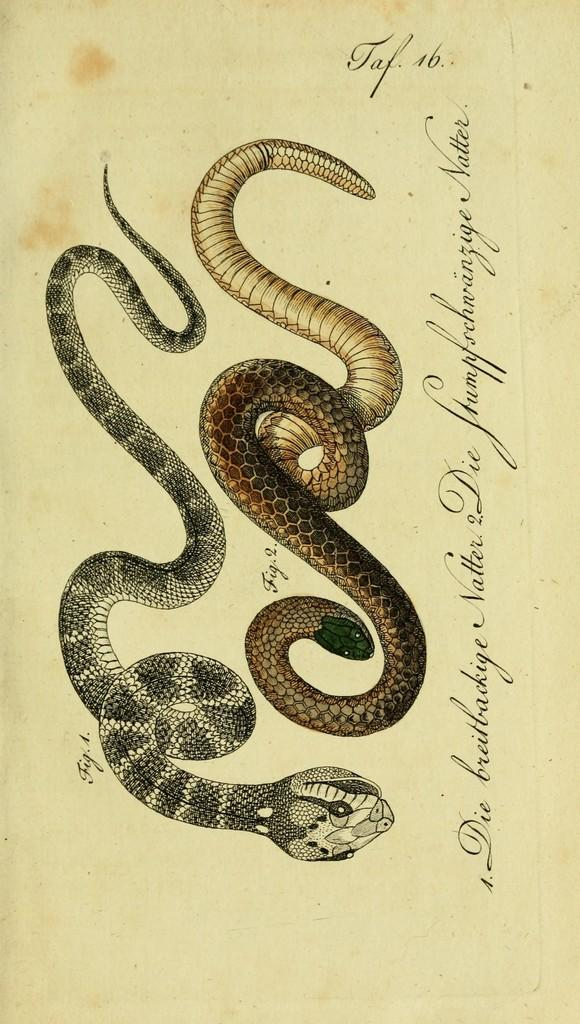What type of animals are shown on the page? There are snakes depicted on the page. What else can be found on the page besides the images of snakes? There is text present on the page. How many kitties are listed on the receipt in the image? There is no receipt or kitties present in the image; it only features snakes and text. 